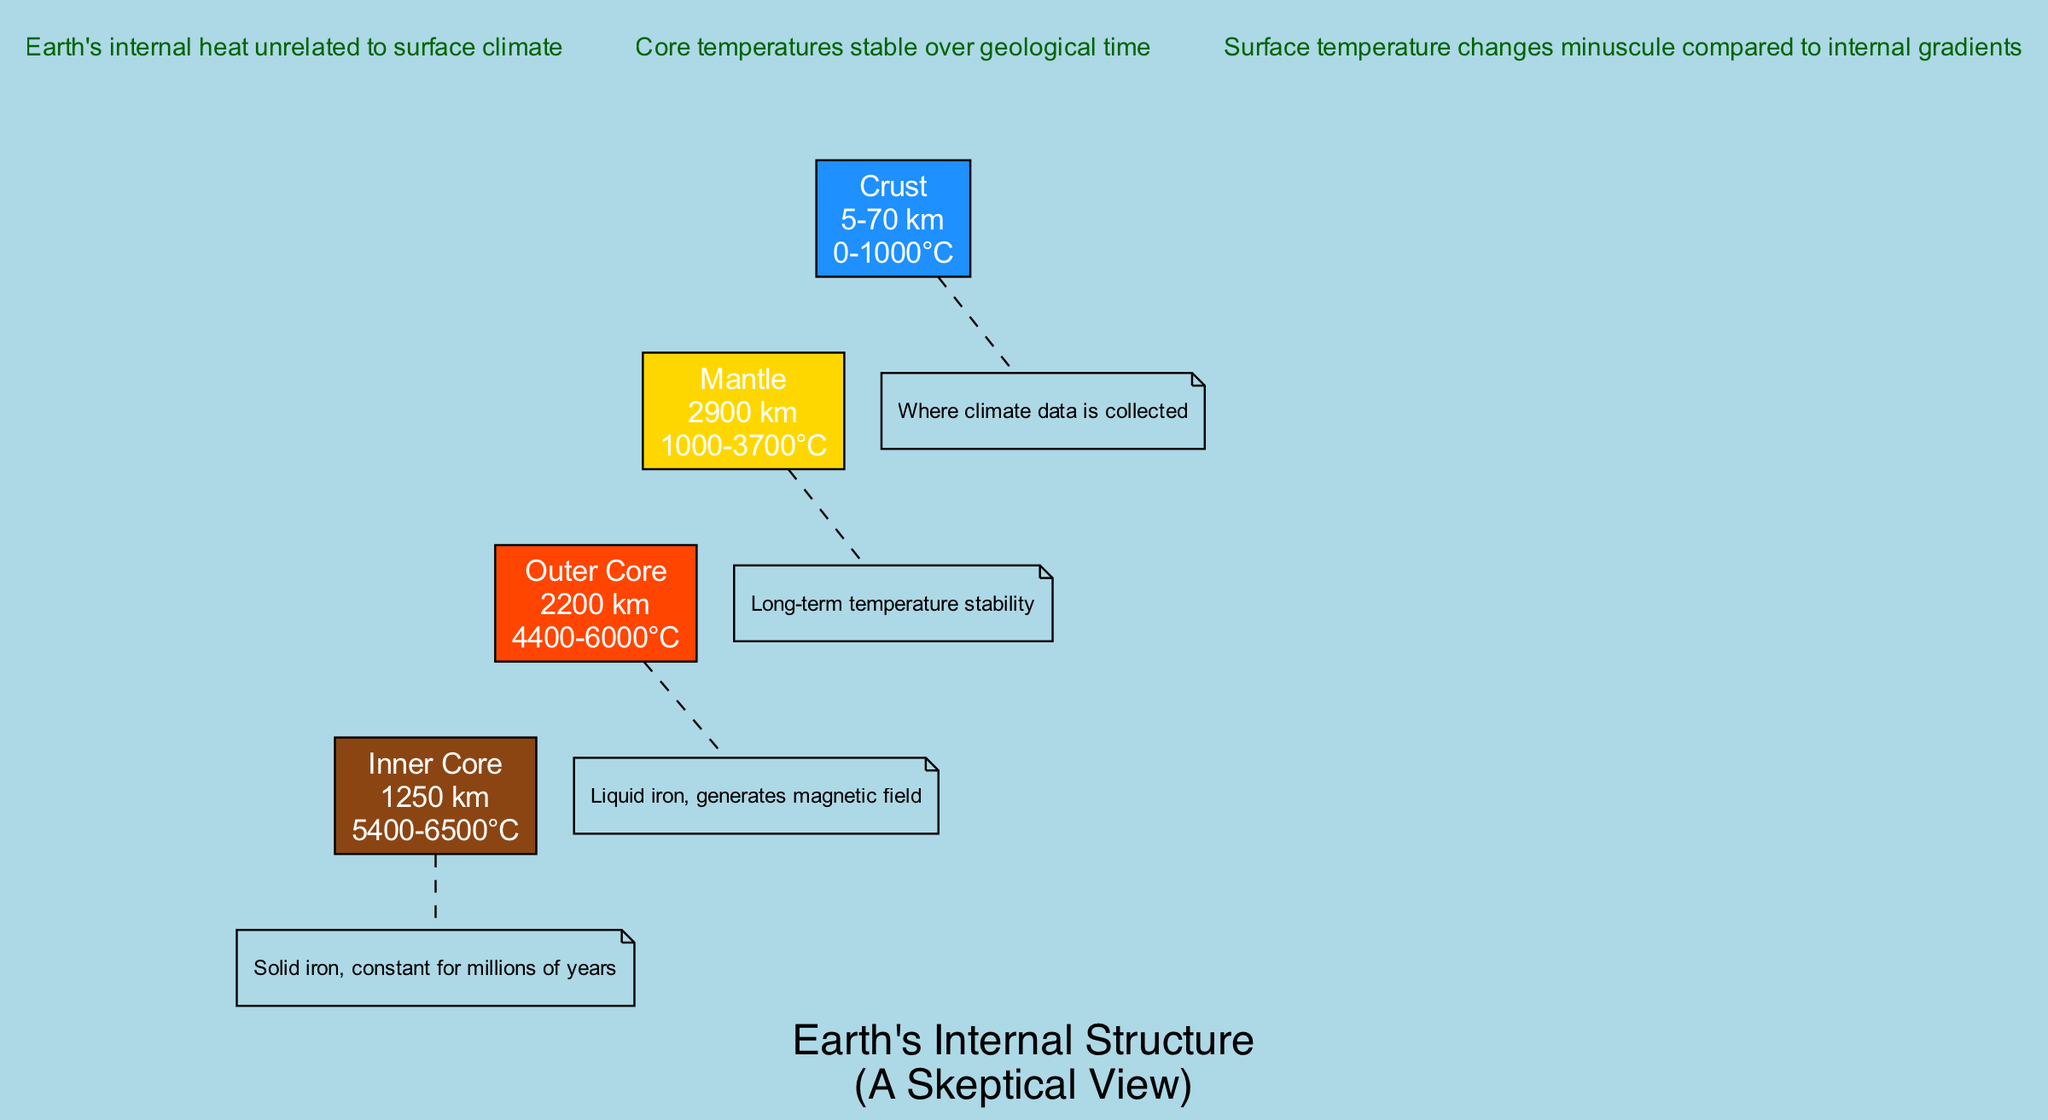What is the thickness of the Outer Core? The diagram specifies that the Outer Core has a thickness of 2200 km. This value is directly taken from the details presented for the Outer Core in the diagram.
Answer: 2200 km What is the temperature range of the Inner Core? According to the diagram, the Inner Core has a temperature range between 5400 and 6500 degrees Celsius. This value is explicitly mentioned for the Inner Core.
Answer: 5400-6500°C Which layer is where climate data is collected? The diagram indicates that the Crust is the layer where climate data is collected. This information is noted specifically under the description of the Crust layer.
Answer: Crust How many layers are depicted in this diagram? The diagram shows a total of four layers: Crust, Mantle, Outer Core, and Inner Core. This count is derived from the number of distinct layers listed in the data provided.
Answer: Four What temperature is the Mantle associated with? The Mantle is associated with a temperature range of 1000 to 3700 degrees Celsius, as stated in the details for the Mantle layer depicted in the diagram.
Answer: 1000-3700°C What is the relationship between Earth's internal heat and surface climate according to the annotations? The annotation states that Earth's internal heat is unrelated to surface climate, indicating a clear distinction between internal temperature stability and surface climate fluctuations. This highlights the independence of internal processes from surface conditions.
Answer: Unrelated Which layer generates the magnetic field? The Outer Core is noted as the layer that generates the magnetic field, as it consists of liquid iron. This information is directly sourced from the description provided for the Outer Core.
Answer: Outer Core What does the note for the Inner Core say? The note for the Inner Core states that it is solid iron and has had constant temperatures for millions of years. This is directly referenced in the description panel for the Inner Core in the diagram.
Answer: Solid iron, constant for millions of years 